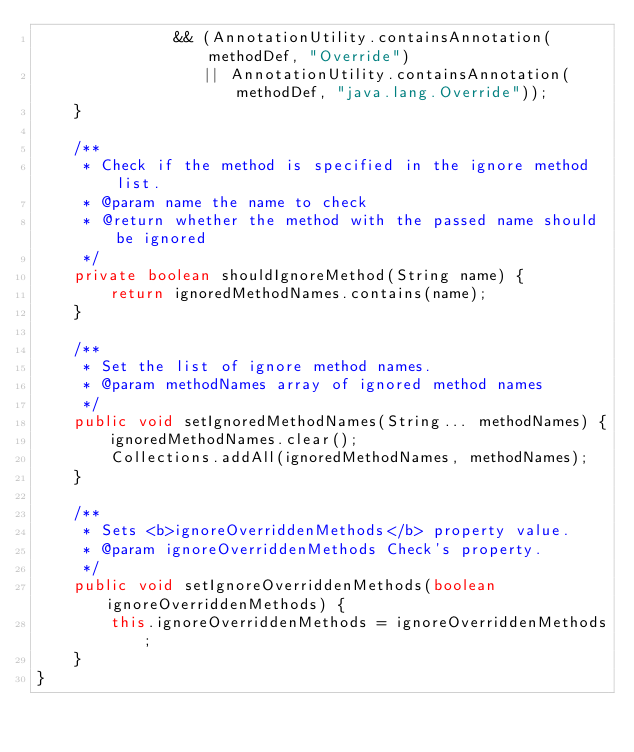Convert code to text. <code><loc_0><loc_0><loc_500><loc_500><_Java_>               && (AnnotationUtility.containsAnnotation(methodDef, "Override")
                  || AnnotationUtility.containsAnnotation(methodDef, "java.lang.Override"));
    }

    /**
     * Check if the method is specified in the ignore method list.
     * @param name the name to check
     * @return whether the method with the passed name should be ignored
     */
    private boolean shouldIgnoreMethod(String name) {
        return ignoredMethodNames.contains(name);
    }

    /**
     * Set the list of ignore method names.
     * @param methodNames array of ignored method names
     */
    public void setIgnoredMethodNames(String... methodNames) {
        ignoredMethodNames.clear();
        Collections.addAll(ignoredMethodNames, methodNames);
    }

    /**
     * Sets <b>ignoreOverriddenMethods</b> property value.
     * @param ignoreOverriddenMethods Check's property.
     */
    public void setIgnoreOverriddenMethods(boolean ignoreOverriddenMethods) {
        this.ignoreOverriddenMethods = ignoreOverriddenMethods;
    }
}
</code> 